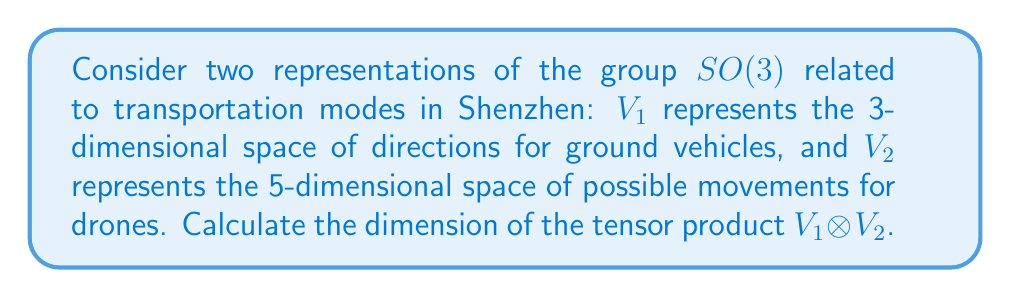Can you answer this question? To solve this problem, we'll follow these steps:

1) First, recall that for two vector spaces $V$ and $W$, the dimension of their tensor product is given by:

   $\dim(V \otimes W) = \dim(V) \cdot \dim(W)$

2) In this case, we have:
   $V_1$: 3-dimensional space (ground vehicles)
   $V_2$: 5-dimensional space (drones)

3) Applying the formula:

   $\dim(V_1 \otimes V_2) = \dim(V_1) \cdot \dim(V_2)$

4) Substituting the given dimensions:

   $\dim(V_1 \otimes V_2) = 3 \cdot 5$

5) Calculating the result:

   $\dim(V_1 \otimes V_2) = 15$

Therefore, the tensor product $V_1 \otimes V_2$ is a 15-dimensional vector space.
Answer: 15 